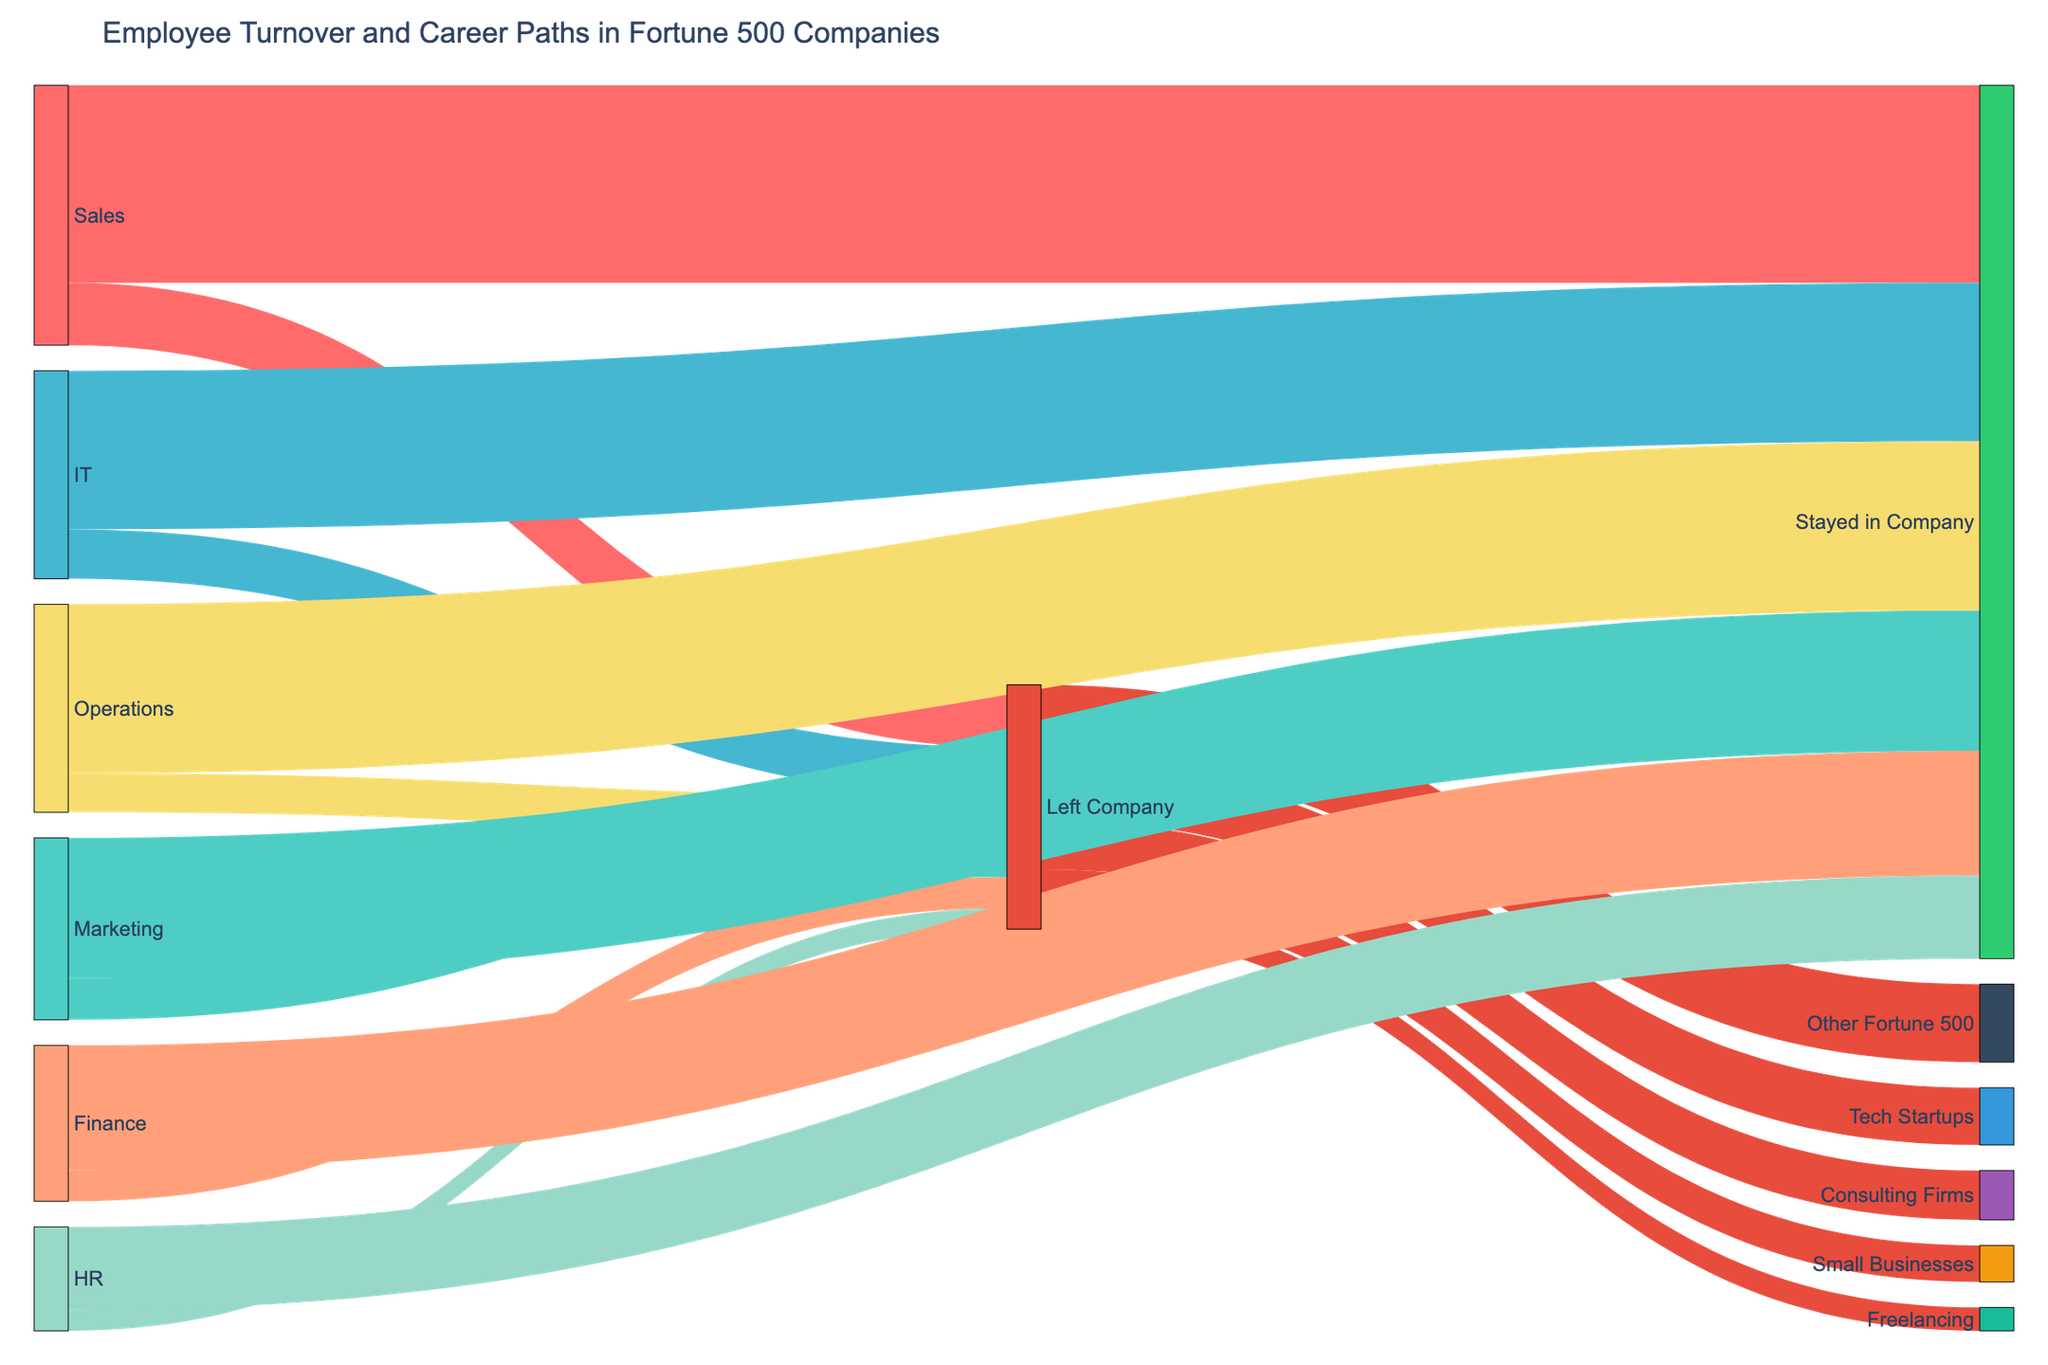what's the overall title of the figure? The overall title is usually found at the top of the figure, in this case, it is clearly labeled.
Answer: Employee Turnover and Career Paths in Fortune 500 Companies How many employees from the IT department stayed in the company? Look at the section where "IT" connects to other flows; count how many connect to "Stayed in Company." The number next to this flow indicates the number of employees.
Answer: 3050 Which department has the highest number of employees who left the company? Look at the sections where each department connects to "Left Company" and identify the maximum value among them.
Answer: Sales What is the combined total of employees from Sales and Marketing who stayed in the company? Look at the flows "Sales -> Stayed in Company" and "Marketing -> Stayed in Company," sum their values: 3800 (Sales) + 2700 (Marketing).
Answer: 6500 Compare the number of employees who left and stayed in HR. Which is higher and by how much? Check the flow values of HR to "Left Company" and "Stayed in Company," and calculate the difference: 1600 (Stayed) - 400 (Left).
Answer: Stayed is higher by 1200 What proportion of employees who left the company joined Tech Startups? Among the total employees who left the company, identify the portion that went to Tech Startups: Total employees who left = 1200 + 800 + 950 + 600 + 400 + 750 = 4700, Employees to Tech Startups = 1100. So, 1100 / 4700.
Answer: 23.4% Which career path did the most former employees go into after leaving the company? Identify the maximum value among the flows originating from "Left Company" to various career paths: Look at 1100 (Tech Startups), 950 (Consulting Firms), 1500 (Other Fortune 500), 700 (Small Businesses), and 450 (Freelancing).
Answer: Other Fortune 500 What is the difference in the number of employees that moved to small businesses compared to freelancing after they left the company? Check the values of employees who moved to Small Businesses and Freelancing and find the difference: 700 (Small Businesses) - 450 (Freelancing).
Answer: 250 In which department was the lowest turnover rate to other Fortune 500 companies? Investigate the flow values to "Other Fortune 500." The highest flow would indicate the lowest turnover rate for that department, followed by comparing the turnover numbers.
Answer: Sales 